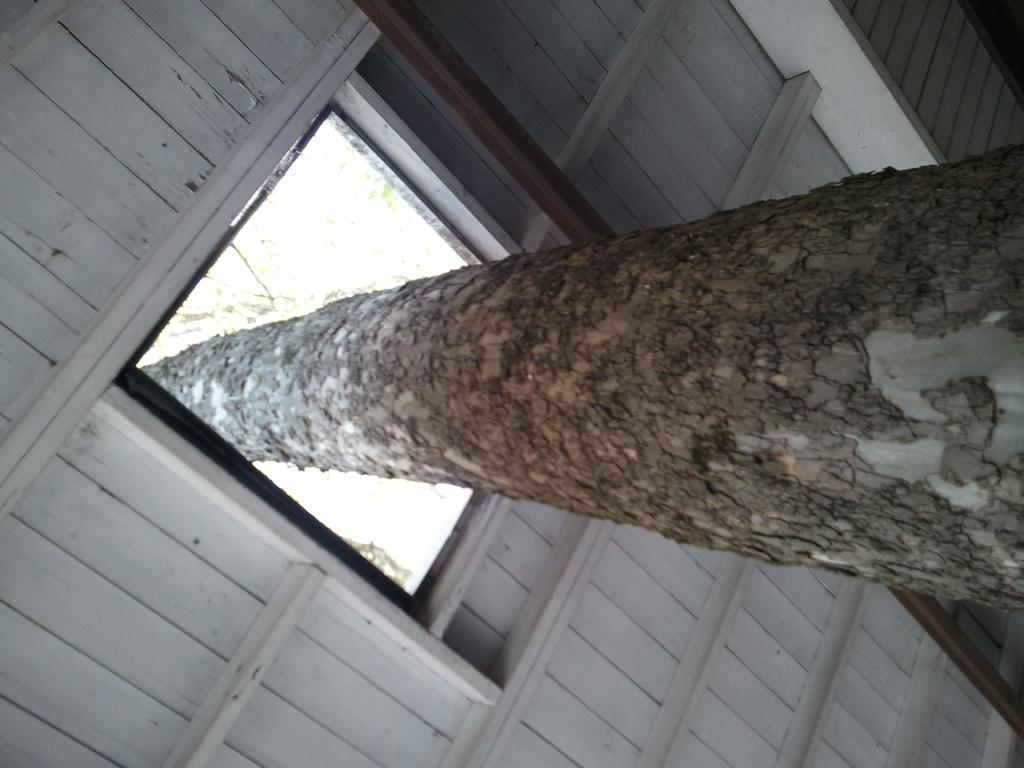What type of object can be seen in the image that is made of wood? There is a tree trunk and a wooden ceiling in the image. Can you describe the wooden ceiling in the image? The wooden ceiling is visible in the image. What type of wire is used to support the stage in the image? There is no stage present in the image, so there is no wire supporting it. Where is the drain located in the image? There is no drain present in the image. 